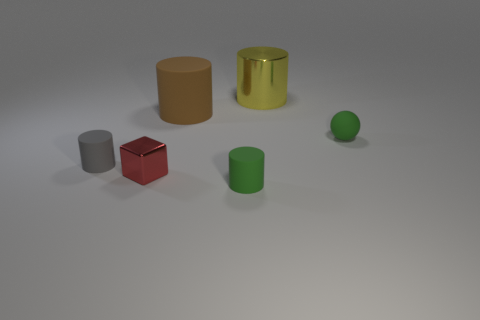What color is the cylinder that is the same material as the tiny red thing?
Keep it short and to the point. Yellow. How many large cylinders are the same material as the gray thing?
Make the answer very short. 1. Is the number of gray rubber things right of the green sphere the same as the number of small rubber cylinders that are behind the tiny gray matte cylinder?
Keep it short and to the point. Yes. There is a small gray matte thing; is it the same shape as the big object that is behind the big brown rubber cylinder?
Your answer should be very brief. Yes. There is a small object that is the same color as the matte ball; what material is it?
Keep it short and to the point. Rubber. Are there any other things that have the same shape as the red metal object?
Offer a very short reply. No. Do the small gray cylinder and the yellow object that is right of the red thing have the same material?
Your answer should be compact. No. There is a tiny cylinder that is behind the green matte object that is on the left side of the tiny green rubber object behind the small green cylinder; what color is it?
Your response must be concise. Gray. There is a small ball; does it have the same color as the small rubber cylinder on the right side of the small gray matte cylinder?
Your response must be concise. Yes. What color is the sphere?
Offer a very short reply. Green. 